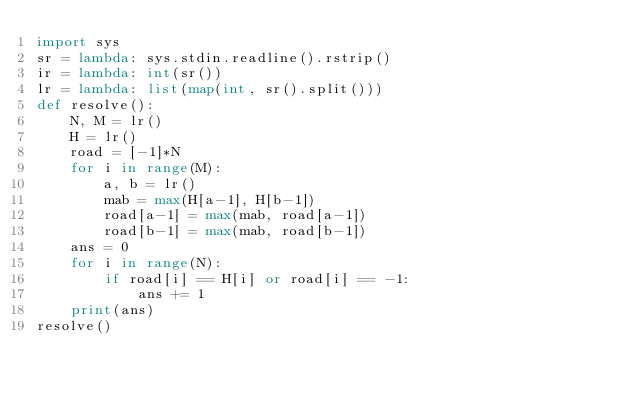<code> <loc_0><loc_0><loc_500><loc_500><_Python_>import sys
sr = lambda: sys.stdin.readline().rstrip()
ir = lambda: int(sr())
lr = lambda: list(map(int, sr().split()))
def resolve():
    N, M = lr()
    H = lr()
    road = [-1]*N
    for i in range(M):
        a, b = lr()
        mab = max(H[a-1], H[b-1])
        road[a-1] = max(mab, road[a-1])
        road[b-1] = max(mab, road[b-1])
    ans = 0
    for i in range(N):
        if road[i] == H[i] or road[i] == -1:
            ans += 1
    print(ans)
resolve()</code> 